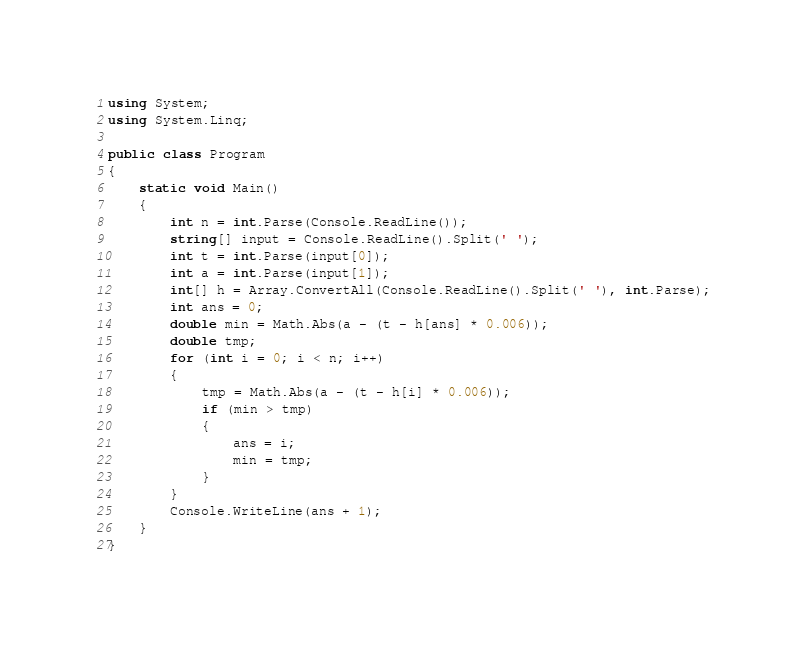<code> <loc_0><loc_0><loc_500><loc_500><_C#_>using System;
using System.Linq;

public class Program
{
    static void Main()
    {
        int n = int.Parse(Console.ReadLine());
        string[] input = Console.ReadLine().Split(' ');
        int t = int.Parse(input[0]);
        int a = int.Parse(input[1]);
        int[] h = Array.ConvertAll(Console.ReadLine().Split(' '), int.Parse);
        int ans = 0;
        double min = Math.Abs(a - (t - h[ans] * 0.006));
        double tmp;
        for (int i = 0; i < n; i++)
        {
            tmp = Math.Abs(a - (t - h[i] * 0.006));
            if (min > tmp)
            {
                ans = i;
                min = tmp;
            }
        }
        Console.WriteLine(ans + 1);
    }
}</code> 